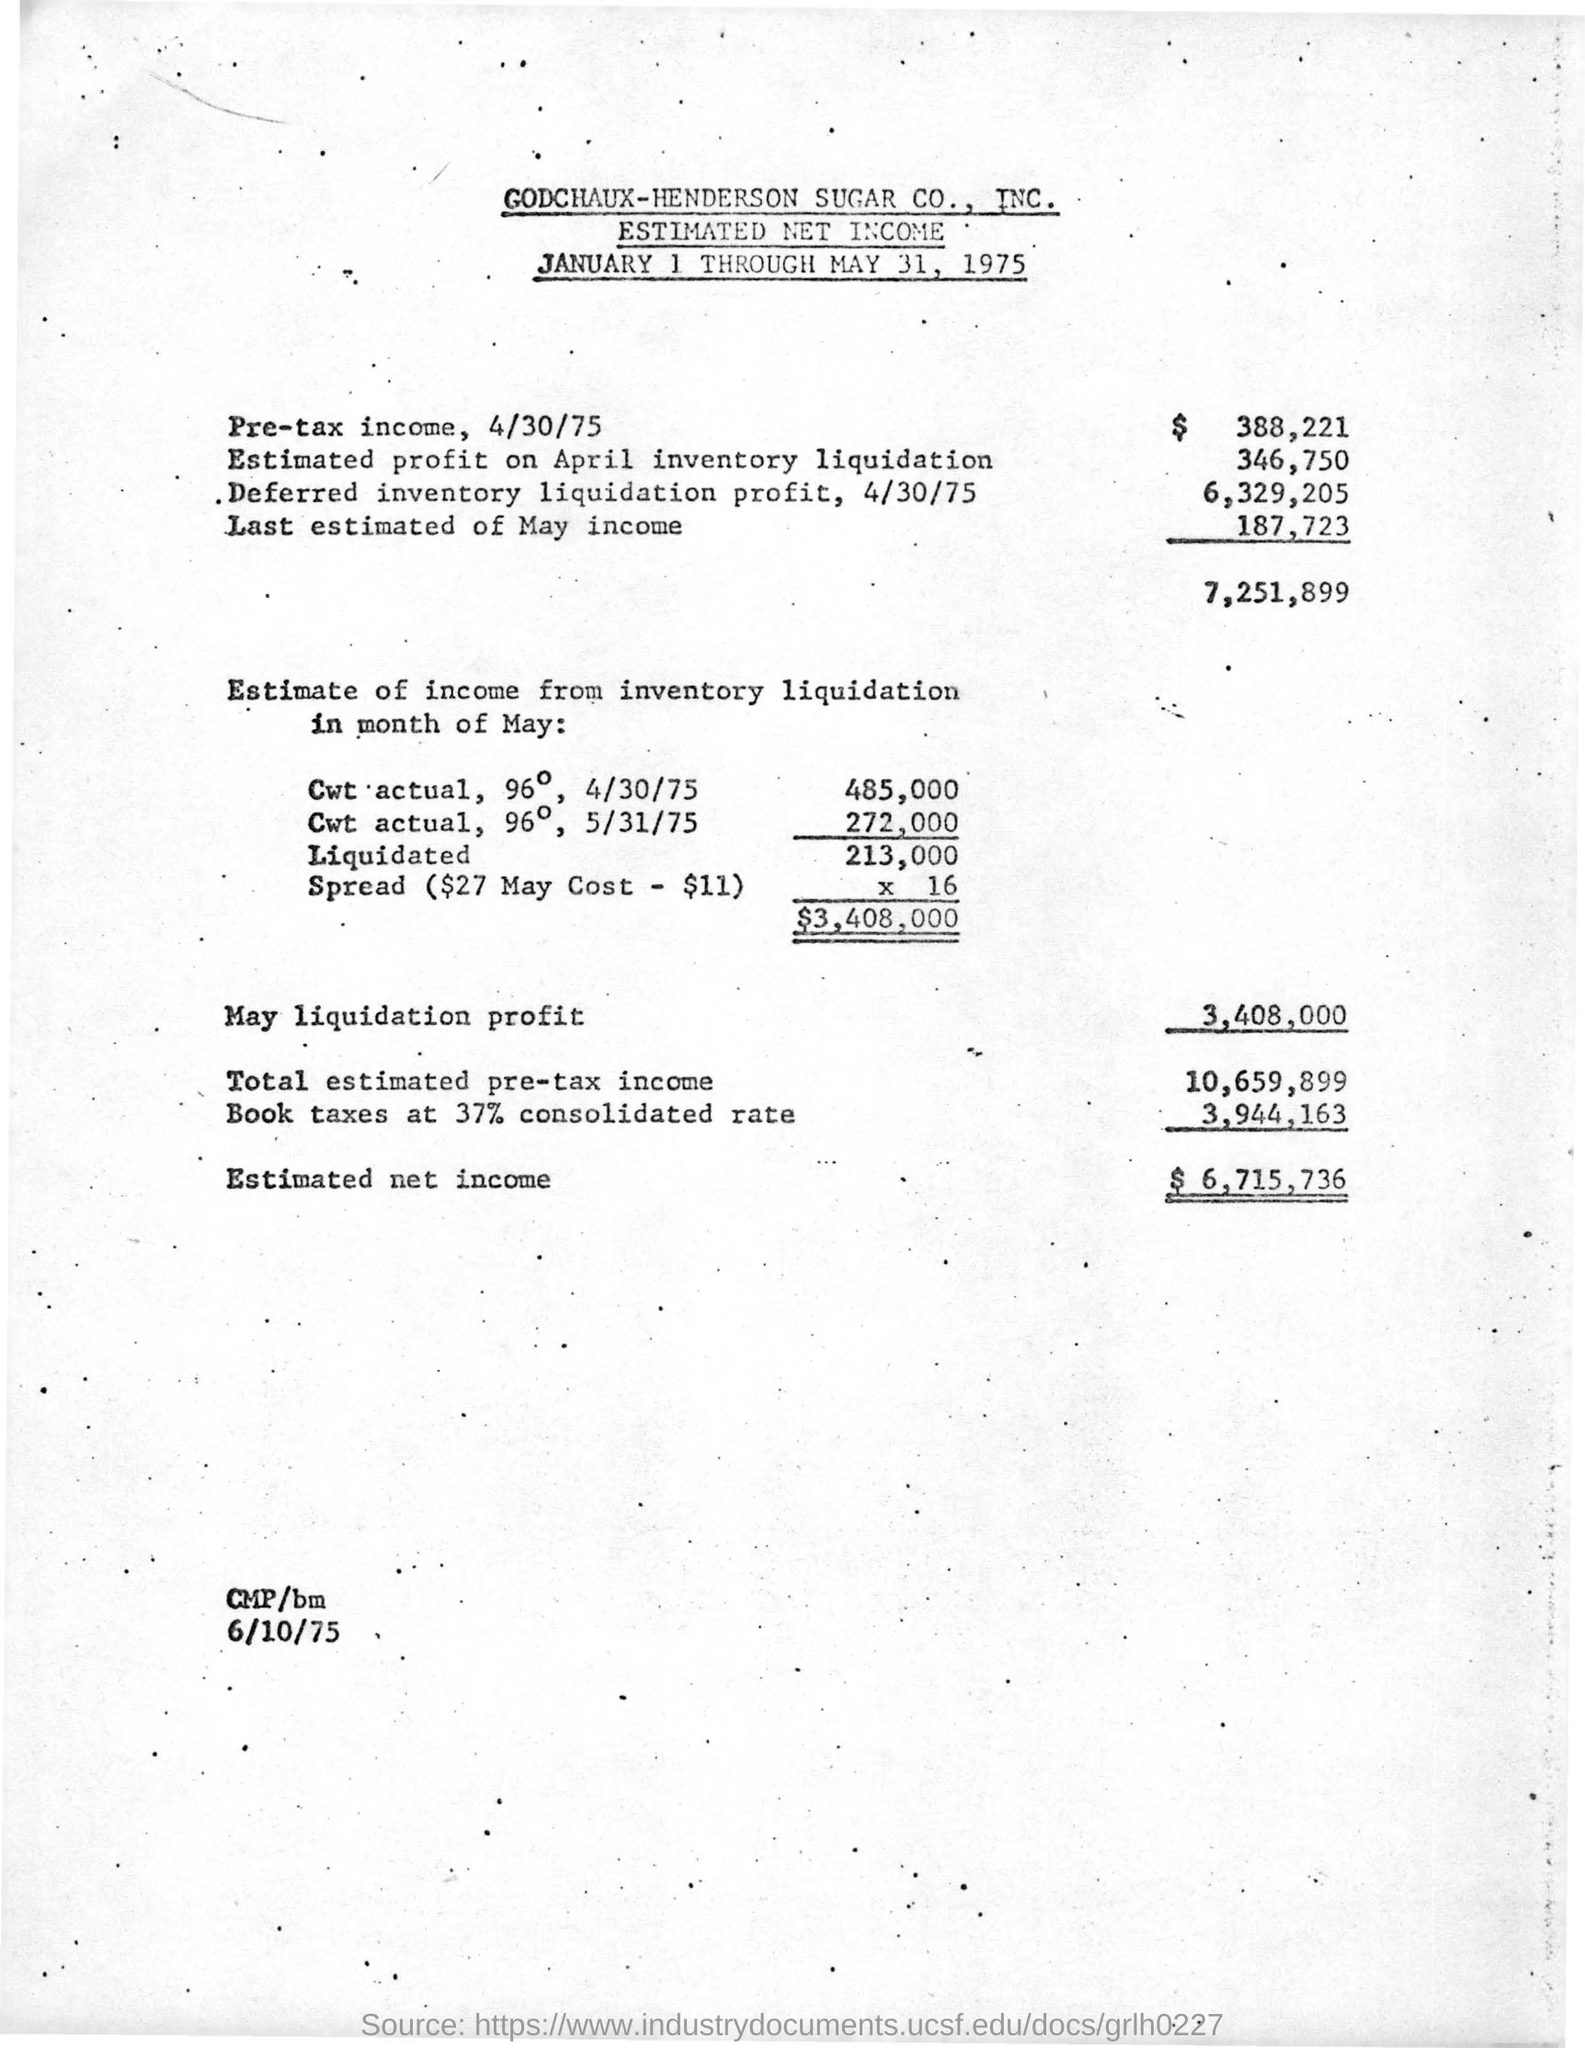Which company's estimated net income is given here?
Your response must be concise. GODCHAUX-HENDERSON SUGAR CO.,  INC. What is the amount of Pre-tax income, 4/30/75?
Your answer should be very brief. $388,221. How much is the estimated profit on April inventory liquidation?
Keep it short and to the point. 346,750. How much is the Estimated net income?
Your answer should be compact. $6,715,736. 